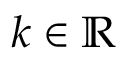Convert formula to latex. <formula><loc_0><loc_0><loc_500><loc_500>k \in \mathbb { R }</formula> 